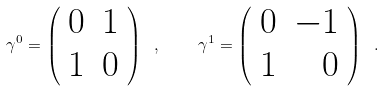Convert formula to latex. <formula><loc_0><loc_0><loc_500><loc_500>\gamma ^ { 0 } = \left ( \begin{array} { r r } 0 & 1 \\ 1 & 0 \end{array} \right ) \ , \quad \gamma ^ { 1 } = \left ( \begin{array} { r r } 0 & - 1 \\ 1 & 0 \end{array} \right ) \ .</formula> 